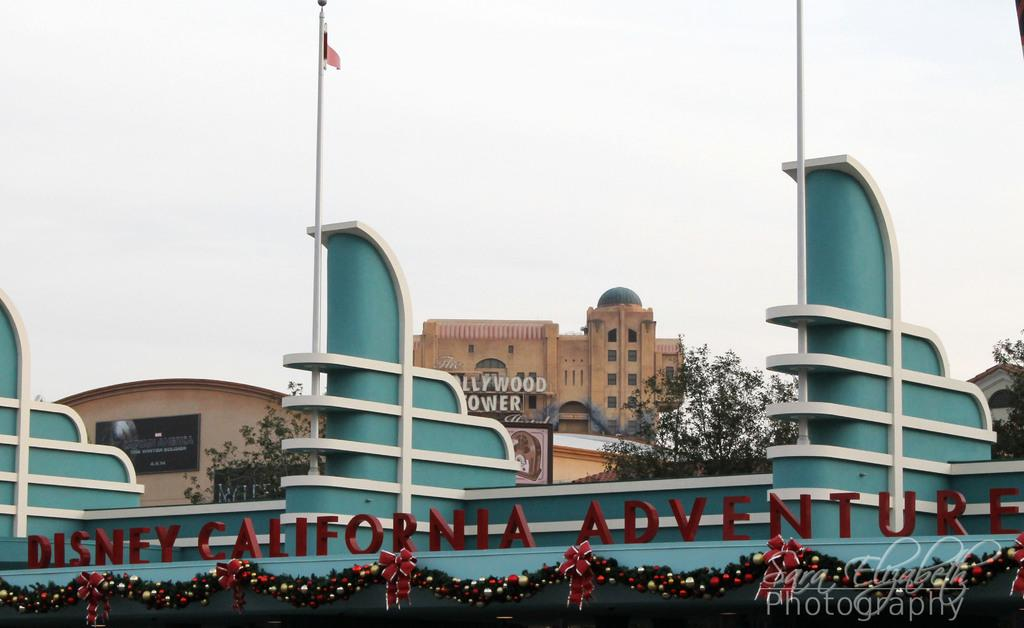What perspective is used to capture the image? The image is taken in a top view. What structures can be seen in the image? There are buildings in the image. What type of vegetation is present in the image? There are trees in the image. What can be seen in the distance in the image? The sky is visible in the background of the image. What type of skin condition can be seen on the trees in the image? There is no mention of any skin condition on the trees in the image, and trees do not have skin. 